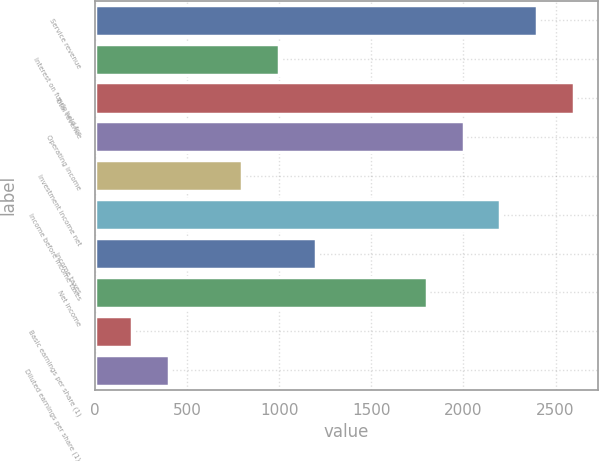<chart> <loc_0><loc_0><loc_500><loc_500><bar_chart><fcel>Service revenue<fcel>Interest on funds held for<fcel>Total revenue<fcel>Operating income<fcel>Investment income net<fcel>Income before income taxes<fcel>Income taxes<fcel>Net income<fcel>Basic earnings per share (1)<fcel>Diluted earnings per share (1)<nl><fcel>2400.76<fcel>1001.04<fcel>2600.72<fcel>2000.84<fcel>801.08<fcel>2200.8<fcel>1201<fcel>1800.88<fcel>201.2<fcel>401.16<nl></chart> 